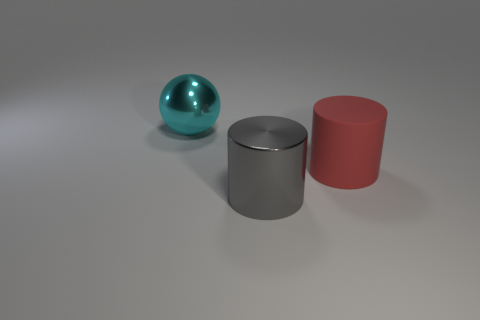Add 1 large balls. How many objects exist? 4 Subtract 1 cylinders. How many cylinders are left? 1 Add 1 tiny matte cubes. How many tiny matte cubes exist? 1 Subtract 0 cyan cylinders. How many objects are left? 3 Subtract all cylinders. How many objects are left? 1 Subtract all yellow cylinders. Subtract all yellow balls. How many cylinders are left? 2 Subtract all rubber cylinders. Subtract all tiny blue cubes. How many objects are left? 2 Add 1 gray metal things. How many gray metal things are left? 2 